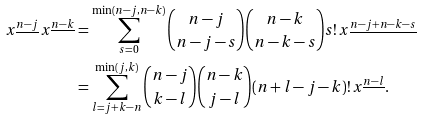Convert formula to latex. <formula><loc_0><loc_0><loc_500><loc_500>x ^ { \underline { n - j } } \, x ^ { \underline { n - k } } & = \sum _ { s = 0 } ^ { \min ( n - j , n - k ) } \binom { n - j } { n - j - s } \binom { n - k } { n - k - s } s ! \, x ^ { \underline { n - j + n - k - s } } \\ & = \sum _ { l = j + k - n } ^ { \min ( j , k ) } \binom { n - j } { k - l } \binom { n - k } { j - l } ( n + l - j - k ) ! \, x ^ { \underline { n - l } } .</formula> 